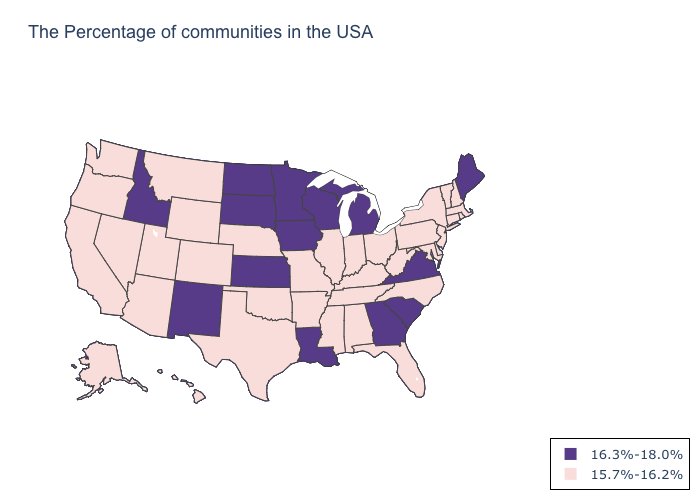Does South Dakota have the highest value in the USA?
Write a very short answer. Yes. Among the states that border Massachusetts , which have the highest value?
Answer briefly. Rhode Island, New Hampshire, Vermont, Connecticut, New York. What is the value of Kansas?
Short answer required. 16.3%-18.0%. Among the states that border Florida , does Georgia have the lowest value?
Be succinct. No. What is the value of Ohio?
Concise answer only. 15.7%-16.2%. What is the lowest value in the USA?
Answer briefly. 15.7%-16.2%. Name the states that have a value in the range 16.3%-18.0%?
Write a very short answer. Maine, Virginia, South Carolina, Georgia, Michigan, Wisconsin, Louisiana, Minnesota, Iowa, Kansas, South Dakota, North Dakota, New Mexico, Idaho. Name the states that have a value in the range 15.7%-16.2%?
Short answer required. Massachusetts, Rhode Island, New Hampshire, Vermont, Connecticut, New York, New Jersey, Delaware, Maryland, Pennsylvania, North Carolina, West Virginia, Ohio, Florida, Kentucky, Indiana, Alabama, Tennessee, Illinois, Mississippi, Missouri, Arkansas, Nebraska, Oklahoma, Texas, Wyoming, Colorado, Utah, Montana, Arizona, Nevada, California, Washington, Oregon, Alaska, Hawaii. What is the highest value in states that border California?
Give a very brief answer. 15.7%-16.2%. What is the lowest value in the USA?
Short answer required. 15.7%-16.2%. What is the lowest value in the MidWest?
Give a very brief answer. 15.7%-16.2%. Which states have the lowest value in the South?
Be succinct. Delaware, Maryland, North Carolina, West Virginia, Florida, Kentucky, Alabama, Tennessee, Mississippi, Arkansas, Oklahoma, Texas. Name the states that have a value in the range 15.7%-16.2%?
Quick response, please. Massachusetts, Rhode Island, New Hampshire, Vermont, Connecticut, New York, New Jersey, Delaware, Maryland, Pennsylvania, North Carolina, West Virginia, Ohio, Florida, Kentucky, Indiana, Alabama, Tennessee, Illinois, Mississippi, Missouri, Arkansas, Nebraska, Oklahoma, Texas, Wyoming, Colorado, Utah, Montana, Arizona, Nevada, California, Washington, Oregon, Alaska, Hawaii. Name the states that have a value in the range 16.3%-18.0%?
Concise answer only. Maine, Virginia, South Carolina, Georgia, Michigan, Wisconsin, Louisiana, Minnesota, Iowa, Kansas, South Dakota, North Dakota, New Mexico, Idaho. Name the states that have a value in the range 15.7%-16.2%?
Write a very short answer. Massachusetts, Rhode Island, New Hampshire, Vermont, Connecticut, New York, New Jersey, Delaware, Maryland, Pennsylvania, North Carolina, West Virginia, Ohio, Florida, Kentucky, Indiana, Alabama, Tennessee, Illinois, Mississippi, Missouri, Arkansas, Nebraska, Oklahoma, Texas, Wyoming, Colorado, Utah, Montana, Arizona, Nevada, California, Washington, Oregon, Alaska, Hawaii. 